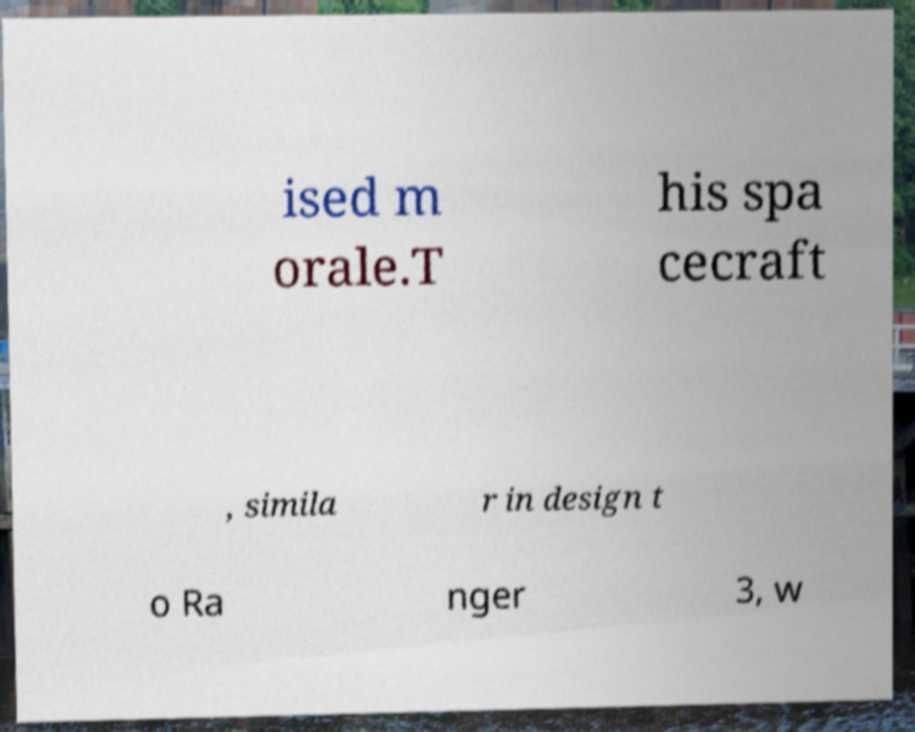There's text embedded in this image that I need extracted. Can you transcribe it verbatim? ised m orale.T his spa cecraft , simila r in design t o Ra nger 3, w 